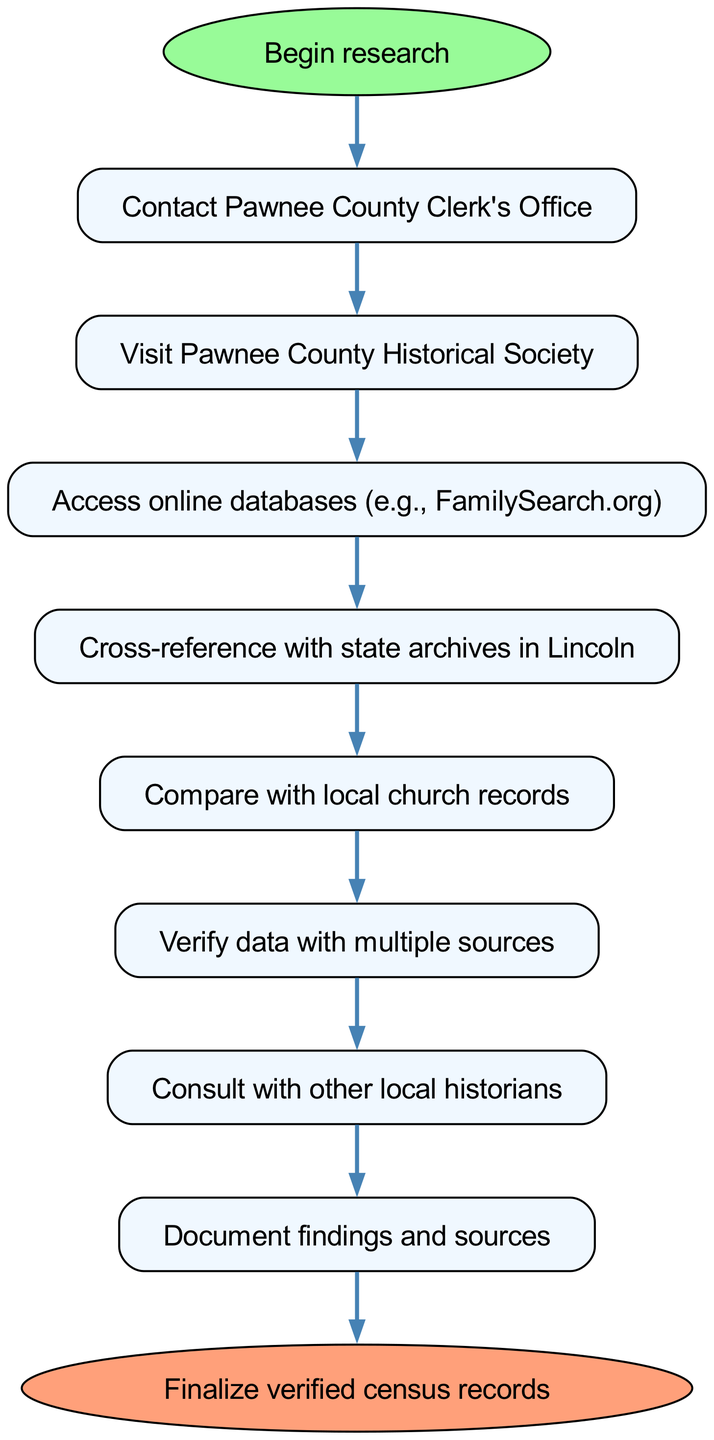What is the first step in the research process? The diagram indicates that the first step is labeled as "Begin research," leading to the next step which is "Contact Pawnee County Clerk's Office."
Answer: Begin research How many nodes are present in the diagram? The diagram shows eight distinct actions or steps with a clear start and end node, totaling ten nodes (including the start and end).
Answer: Ten What action follows after accessing online databases? The diagram illustrates that after "Access online databases (e.g., FamilySearch.org)," the next action is to "Cross-reference with state archives in Lincoln."
Answer: Cross-reference with state archives in Lincoln What is the final action in the research process? According to the diagram, the last action is labeled as "Finalize verified census records." This indicates the completion of the process.
Answer: Finalize verified census records Which step involves consulting others? The chart specifies that "Consult with other local historians" is the step where you collaborate and seek input from fellow historians.
Answer: Consult with other local historians What actions are taken after comparing with local church records? The flow from "Compare with local church records" leads directly to "Verify data with multiple sources," indicating that verification follows church record comparisons.
Answer: Verify data with multiple sources Which node represents accessing information online? The diagram clearly identifies "Access online databases (e.g., FamilySearch.org)" as the node associated with online information access in the research process.
Answer: Access online databases (e.g., FamilySearch.org) How many connections are there in total? By reviewing the diagram, one can count nine connections that link the various processes, leading from the start to the end node in sequential order.
Answer: Nine What are the sources to verify data? Based on the diagram, data should be verified with "multiple sources," including archives, church records, and input from local historians, highlighting cross-verification.
Answer: Multiple sources 